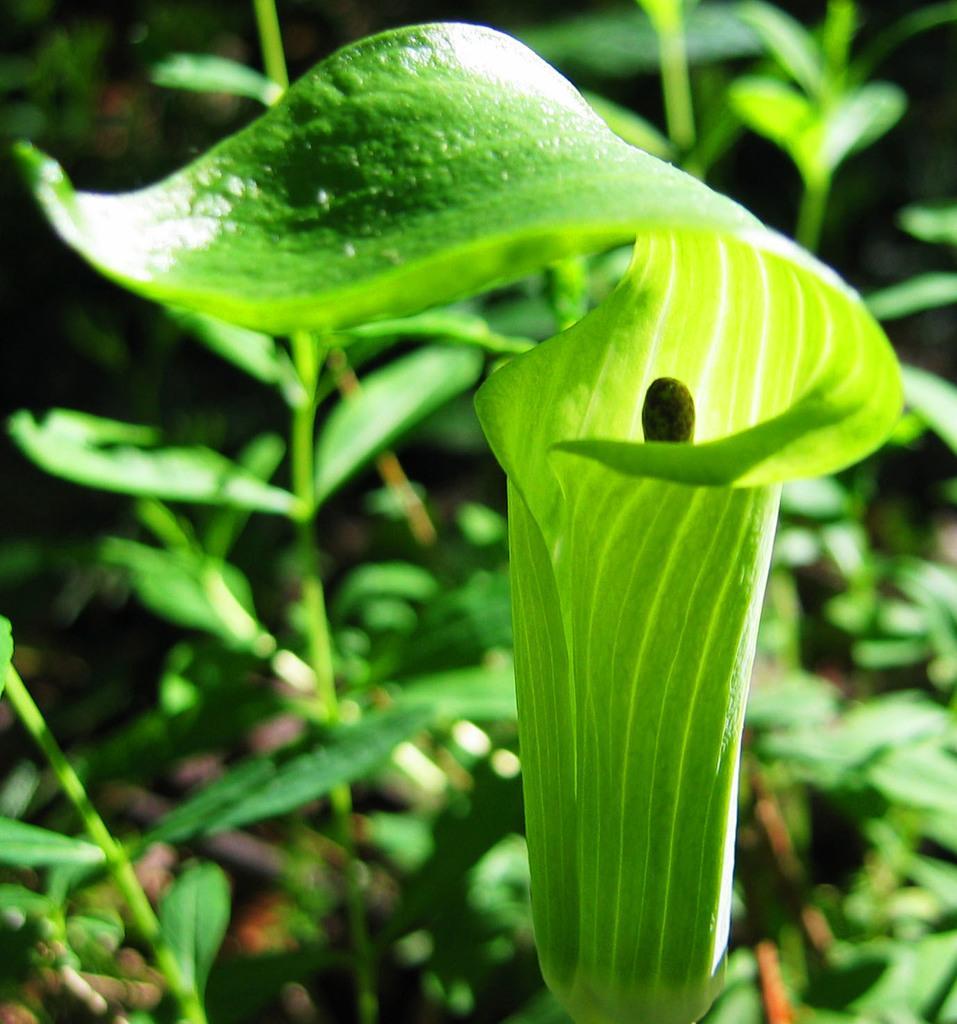Describe this image in one or two sentences. In this image I can see few plants along with the leaves. 